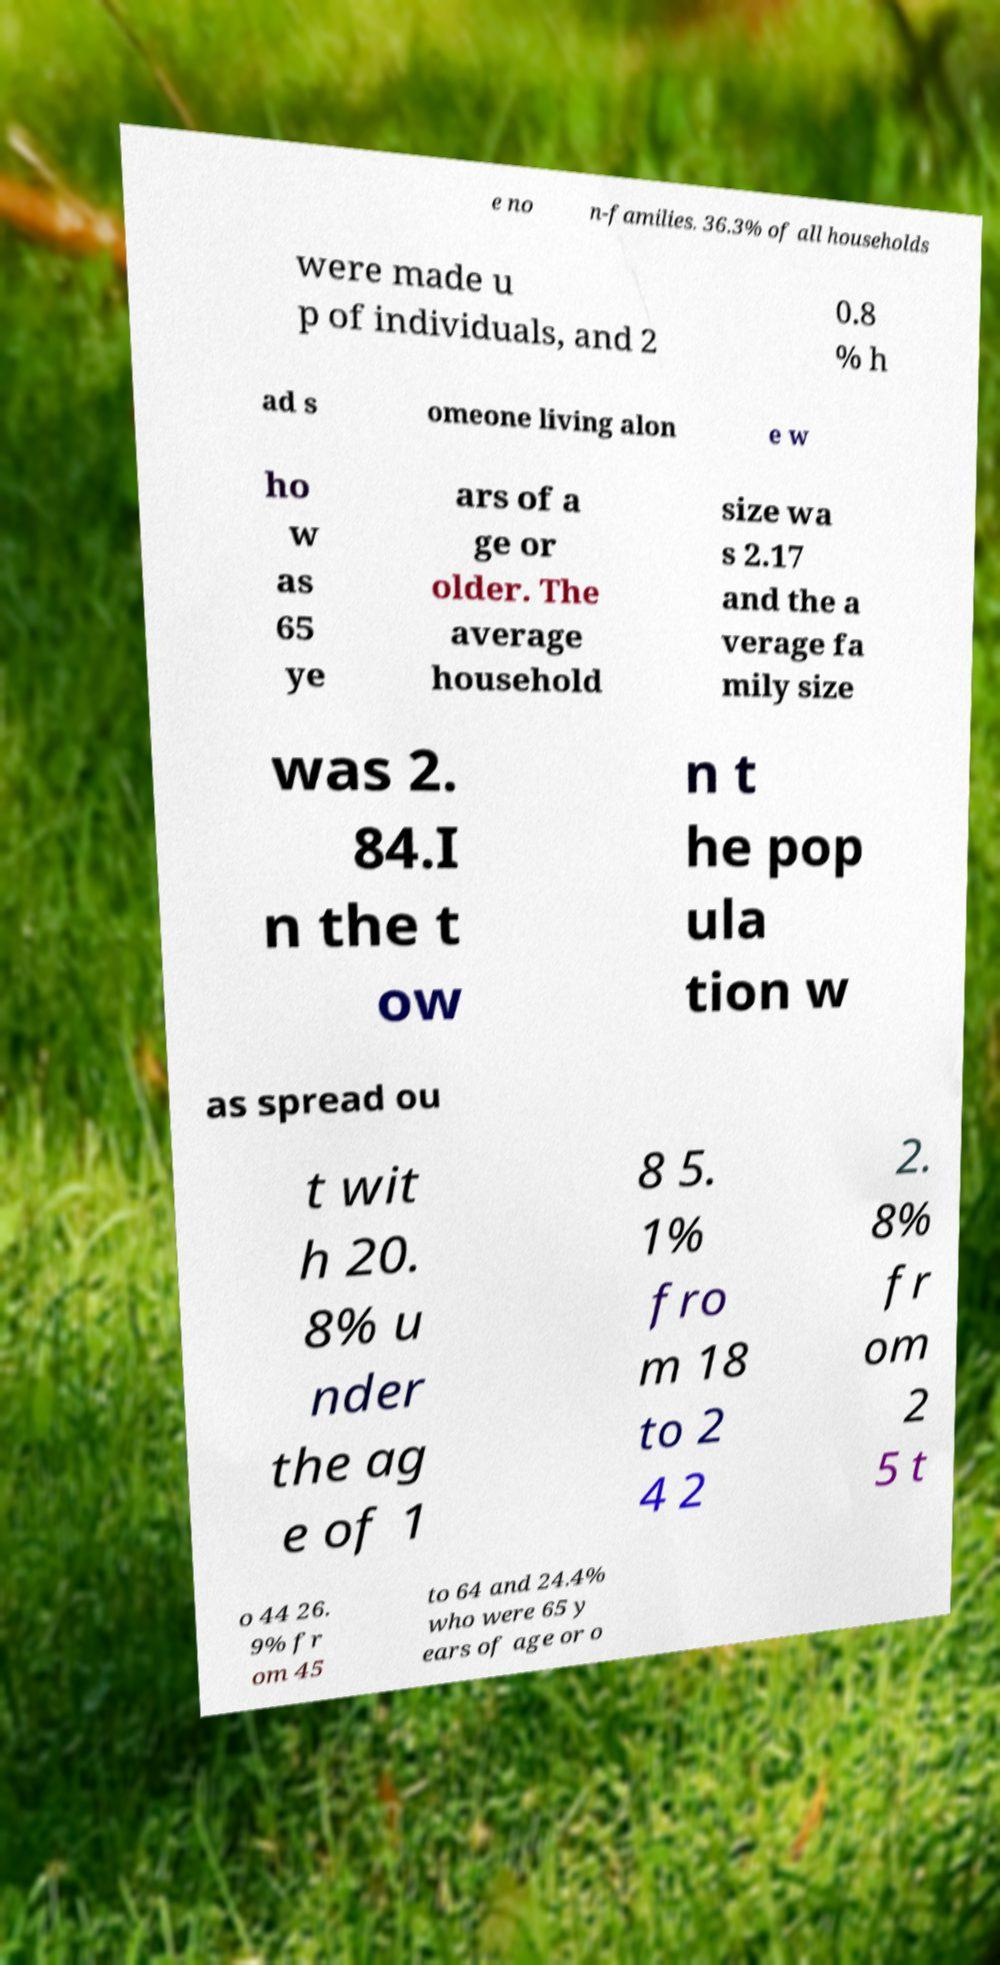What messages or text are displayed in this image? I need them in a readable, typed format. e no n-families. 36.3% of all households were made u p of individuals, and 2 0.8 % h ad s omeone living alon e w ho w as 65 ye ars of a ge or older. The average household size wa s 2.17 and the a verage fa mily size was 2. 84.I n the t ow n t he pop ula tion w as spread ou t wit h 20. 8% u nder the ag e of 1 8 5. 1% fro m 18 to 2 4 2 2. 8% fr om 2 5 t o 44 26. 9% fr om 45 to 64 and 24.4% who were 65 y ears of age or o 